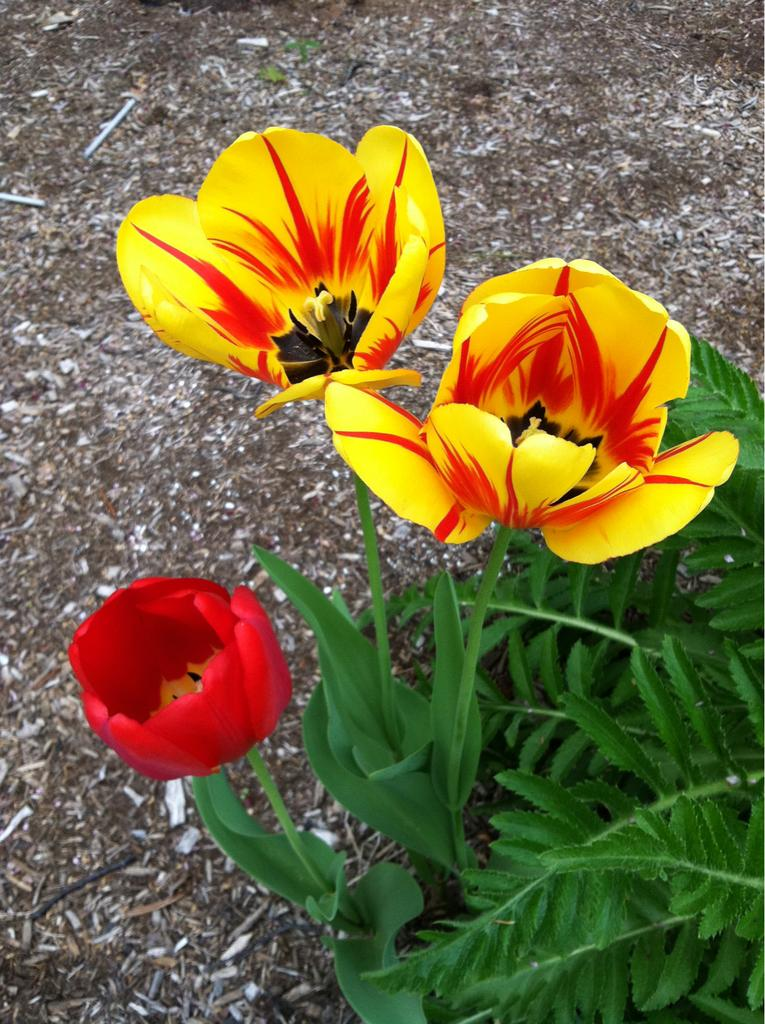What type of living organisms can be seen in the image? Plants and flowers are visible in the image. What is the base material for the plants and flowers in the image? Soil is visible at the top of the image. What type of rabbit can be seen controlling the plants in the image? There is no rabbit present in the image, and the plants are not being controlled by any living organism. 